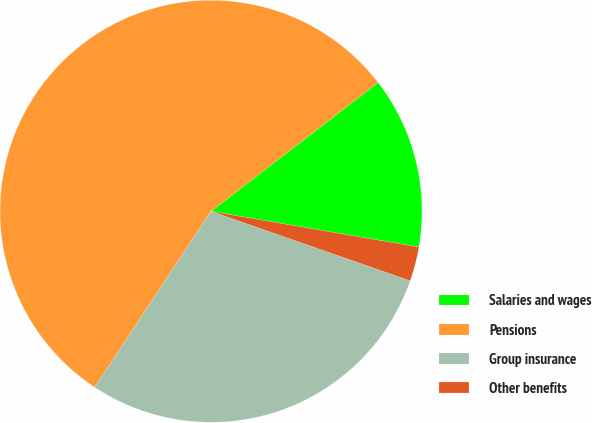Convert chart. <chart><loc_0><loc_0><loc_500><loc_500><pie_chart><fcel>Salaries and wages<fcel>Pensions<fcel>Group insurance<fcel>Other benefits<nl><fcel>13.16%<fcel>55.26%<fcel>28.95%<fcel>2.63%<nl></chart> 